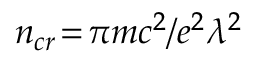<formula> <loc_0><loc_0><loc_500><loc_500>n _ { c r } \, = \, \pi m c ^ { 2 } / e ^ { 2 } \lambda ^ { 2 }</formula> 